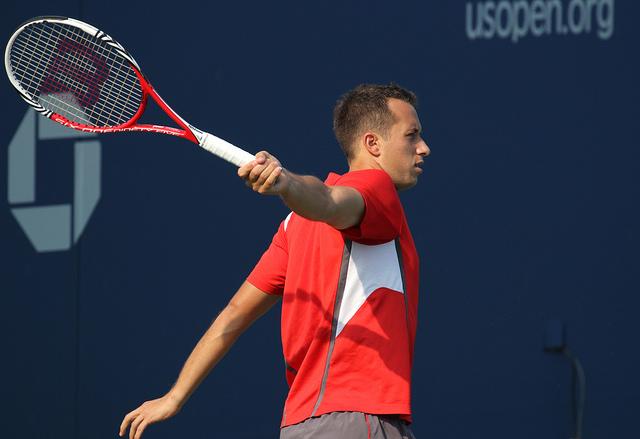What sport is this?
Short answer required. Tennis. What is the man holding?
Keep it brief. Tennis racket. What word is on the background fence?
Be succinct. Usopenorg. What color is the tennis racket?
Give a very brief answer. Red and white. Is this game sponsored?
Concise answer only. Yes. 